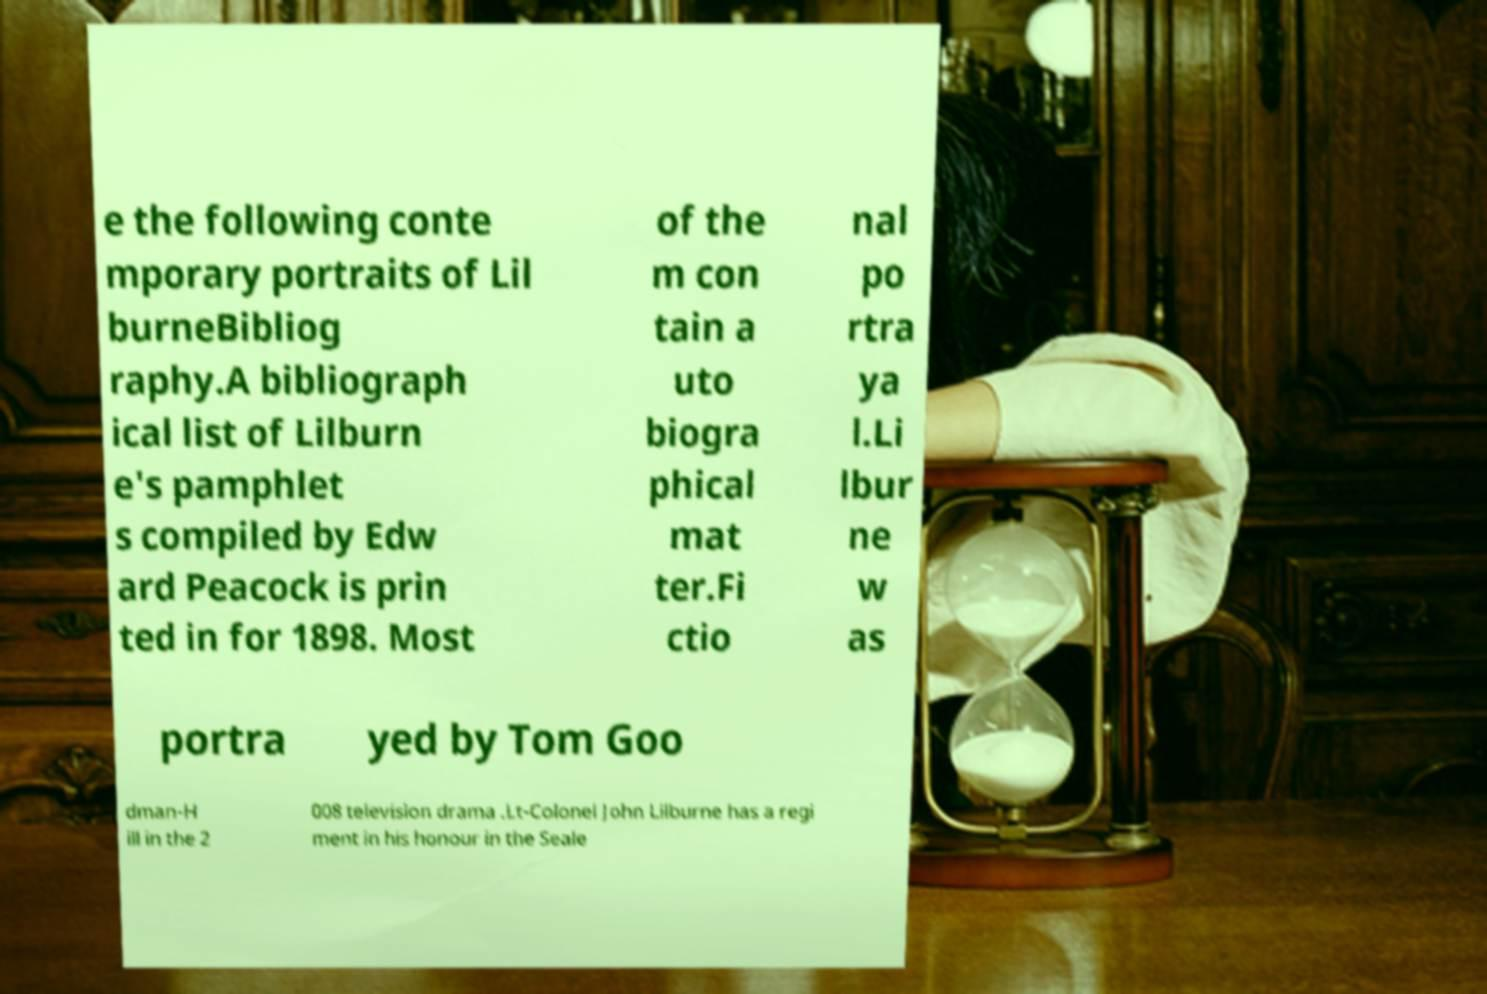There's text embedded in this image that I need extracted. Can you transcribe it verbatim? e the following conte mporary portraits of Lil burneBibliog raphy.A bibliograph ical list of Lilburn e's pamphlet s compiled by Edw ard Peacock is prin ted in for 1898. Most of the m con tain a uto biogra phical mat ter.Fi ctio nal po rtra ya l.Li lbur ne w as portra yed by Tom Goo dman-H ill in the 2 008 television drama .Lt-Colonel John Lilburne has a regi ment in his honour in the Seale 